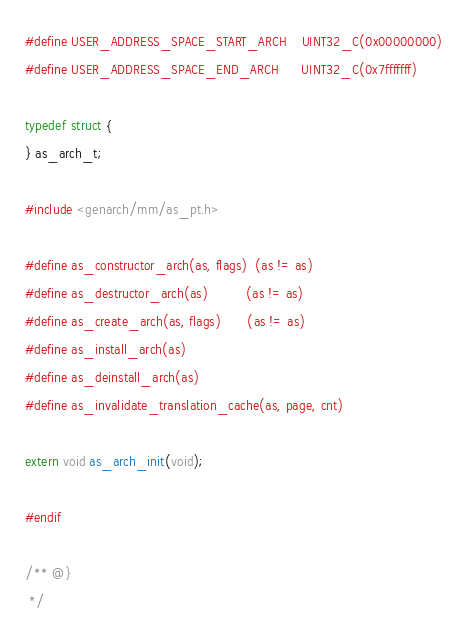Convert code to text. <code><loc_0><loc_0><loc_500><loc_500><_C_>#define USER_ADDRESS_SPACE_START_ARCH    UINT32_C(0x00000000)
#define USER_ADDRESS_SPACE_END_ARCH      UINT32_C(0x7fffffff)

typedef struct {
} as_arch_t;

#include <genarch/mm/as_pt.h>

#define as_constructor_arch(as, flags)  (as != as)
#define as_destructor_arch(as)          (as != as)
#define as_create_arch(as, flags)       (as != as)
#define as_install_arch(as)
#define as_deinstall_arch(as)
#define as_invalidate_translation_cache(as, page, cnt)

extern void as_arch_init(void);

#endif

/** @}
 */
</code> 